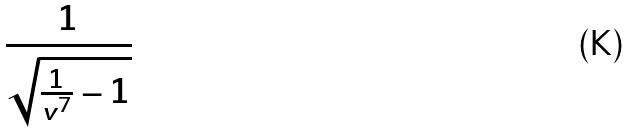<formula> <loc_0><loc_0><loc_500><loc_500>\frac { 1 } { \sqrt { \frac { 1 } { v ^ { 7 } } - 1 } }</formula> 